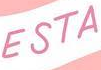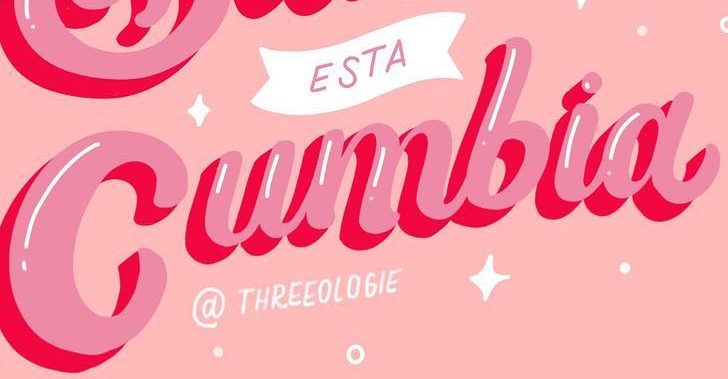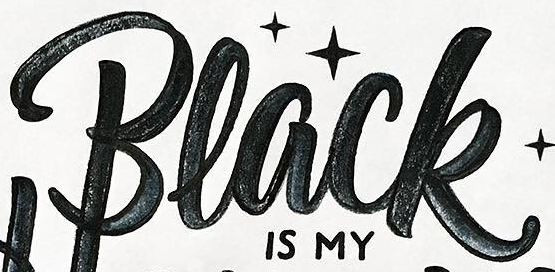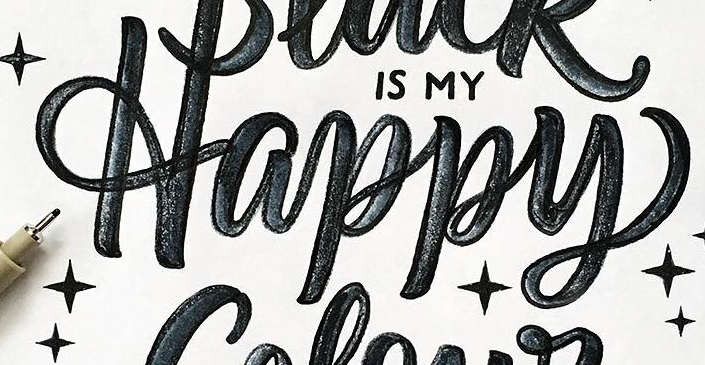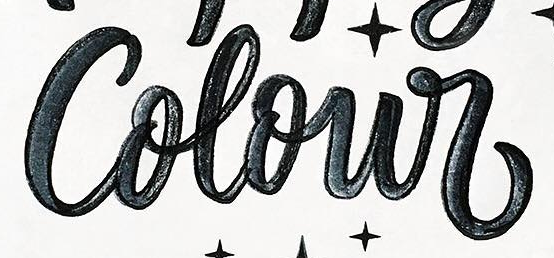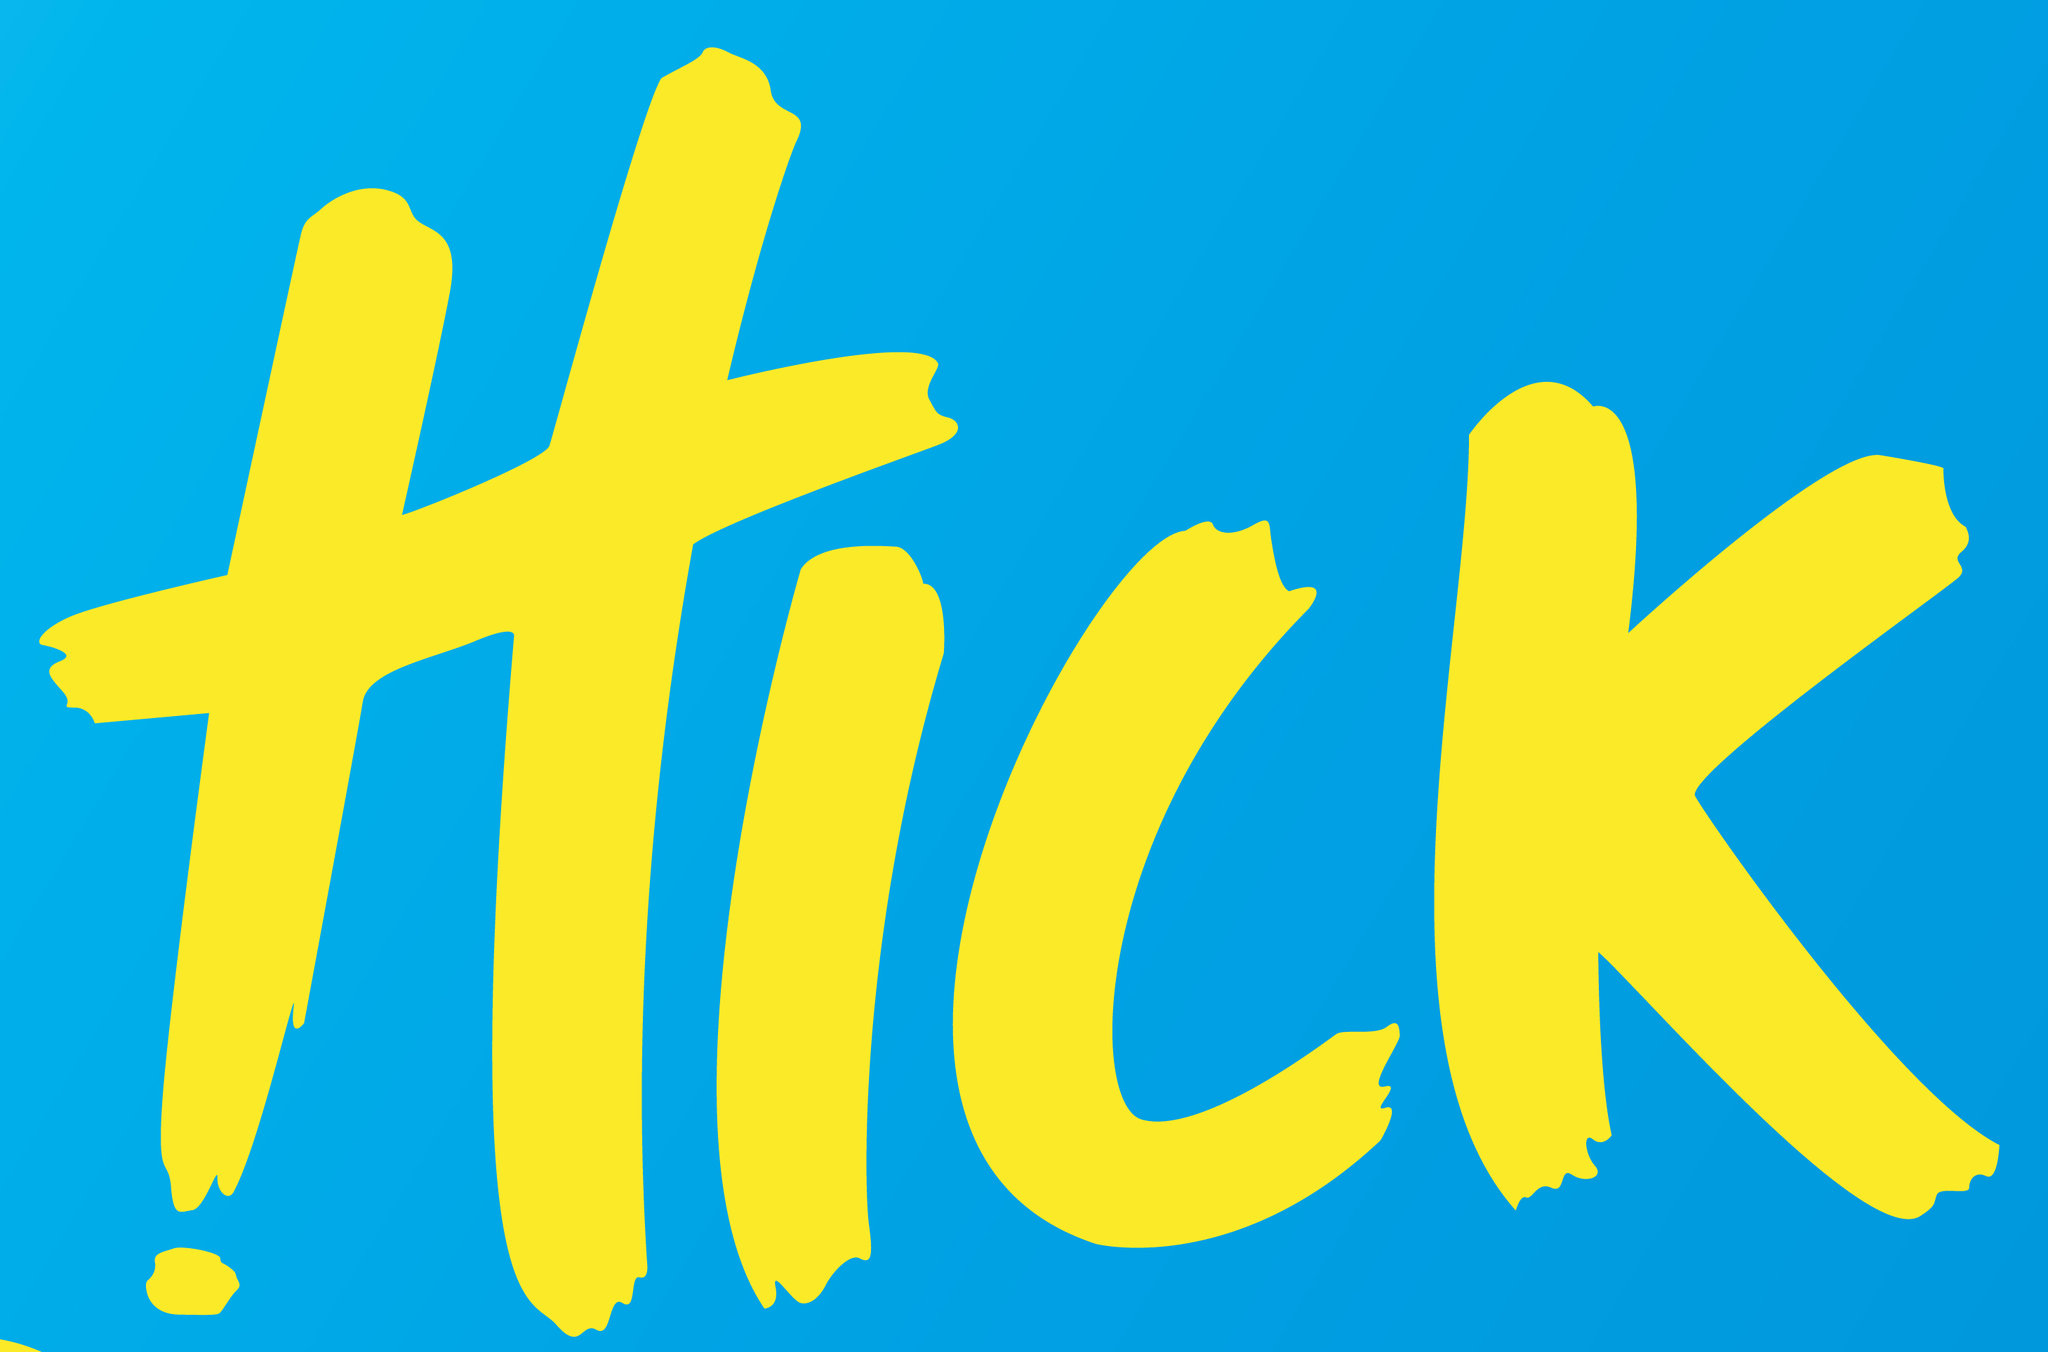What text is displayed in these images sequentially, separated by a semicolon? ESTA; Cumbia; Black; Happy; Colour; HICK 